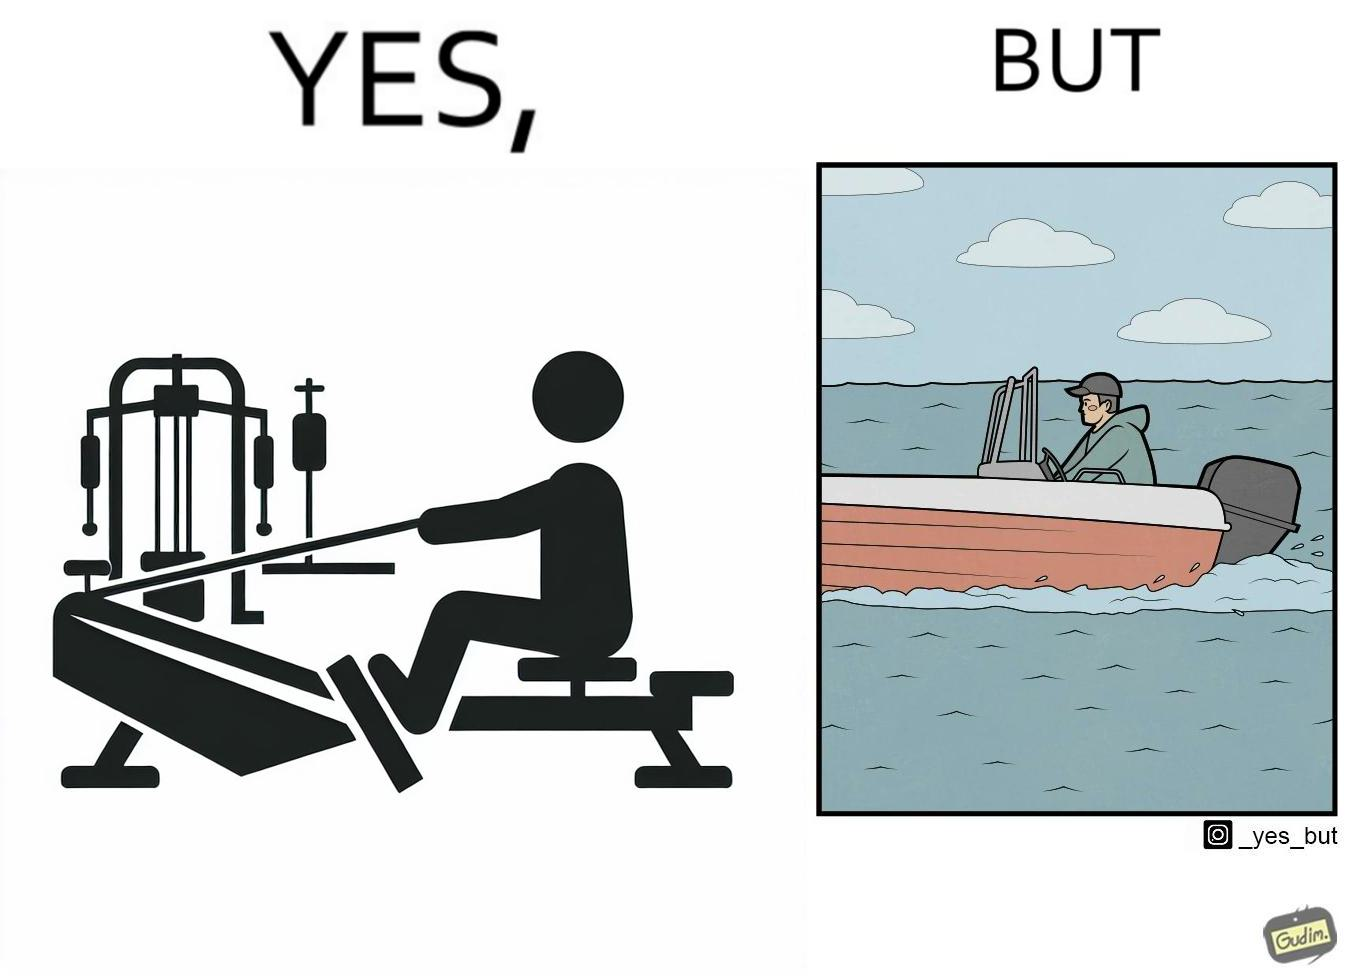What makes this image funny or satirical? The image is ironic, because people often use rowing machine at the gym don't prefer rowing when it comes to boats 